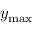Convert formula to latex. <formula><loc_0><loc_0><loc_500><loc_500>y _ { \max }</formula> 